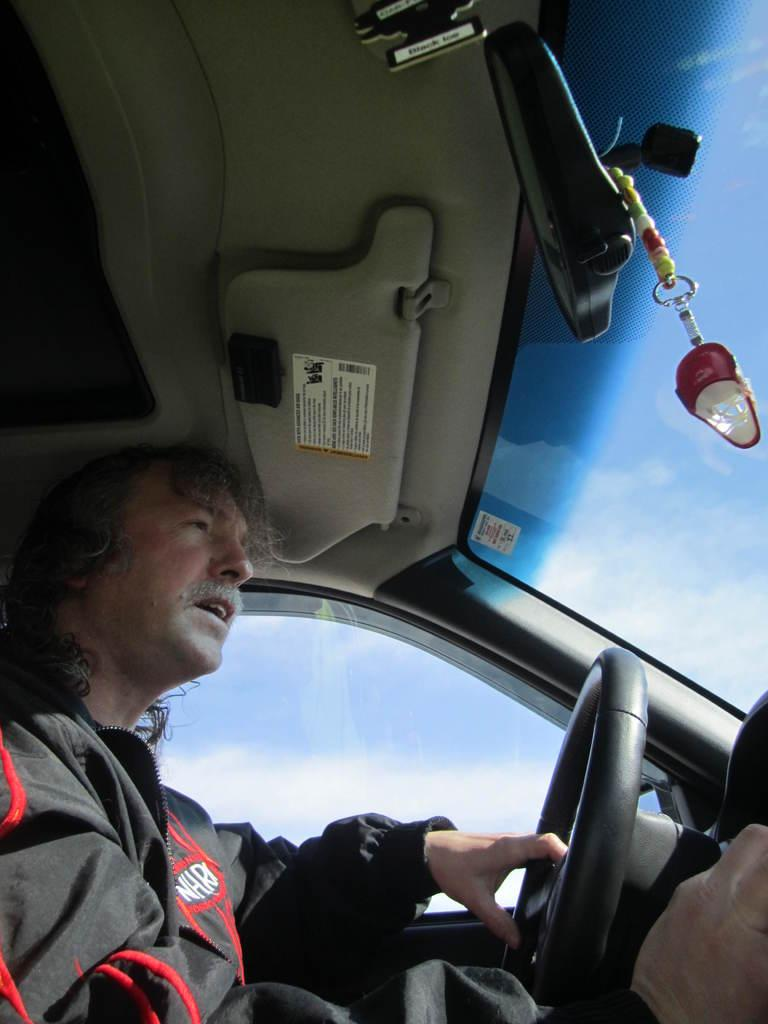What is the main subject of the image? There is a person in the image. What is the person wearing in the image? The person is wearing a black color jacket. What is the person doing in the image? The person is driving a car. What is the person's interest in the image? The provided facts do not mention the person's interests, so it cannot be determined from the image. How many feet can be seen in the image? The image does not show the person's feet, so it cannot be determined from the image. 